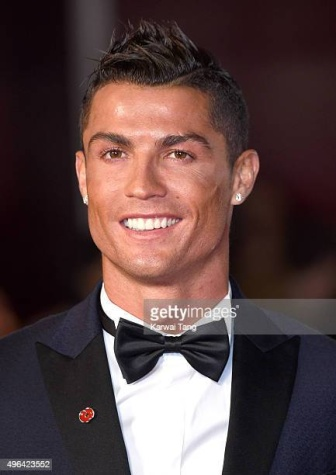How does the crowd in the background contribute to the atmosphere of the image? The blurred crowd in the background of the image contributes significantly to the lively and energetic atmosphere of the event. It suggests that this photo captures a moment of high social interaction, possibly with fans cheering or photographers capturing the moment. This background helps to highlight Ronaldo's status as a highly recognized and celebrated figure in the sports world. 